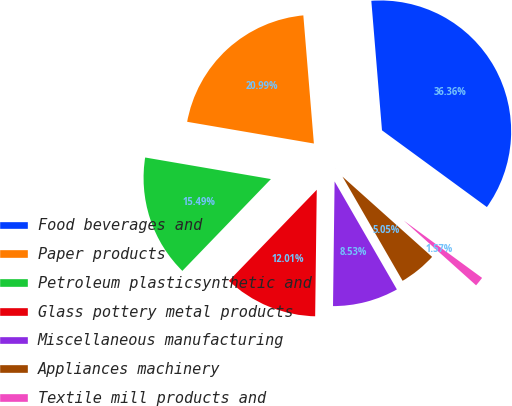Convert chart. <chart><loc_0><loc_0><loc_500><loc_500><pie_chart><fcel>Food beverages and<fcel>Paper products<fcel>Petroleum plasticsynthetic and<fcel>Glass pottery metal products<fcel>Miscellaneous manufacturing<fcel>Appliances machinery<fcel>Textile mill products and<nl><fcel>36.36%<fcel>20.99%<fcel>15.49%<fcel>12.01%<fcel>8.53%<fcel>5.05%<fcel>1.57%<nl></chart> 